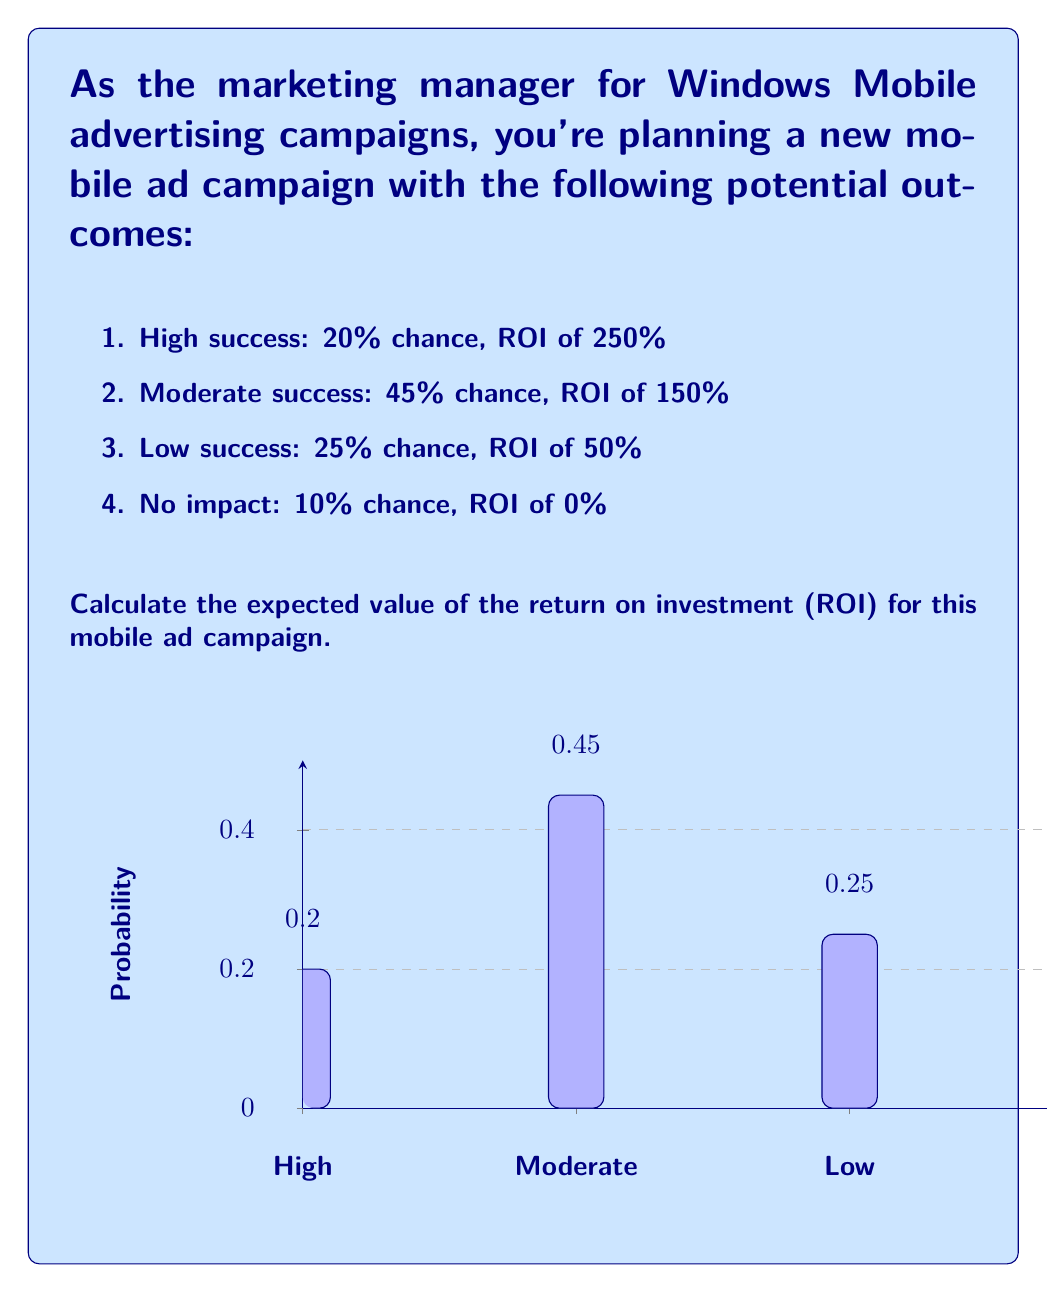Provide a solution to this math problem. To calculate the expected value of the ROI for this mobile ad campaign, we need to multiply each possible ROI by its probability of occurrence and then sum these products. Let's break it down step-by-step:

1) For each outcome, we calculate the product of its ROI and probability:

   High success: $0.20 \times 250\% = 50\%$
   Moderate success: $0.45 \times 150\% = 67.5\%$
   Low success: $0.25 \times 50\% = 12.5\%$
   No impact: $0.10 \times 0\% = 0\%$

2) Now, we sum these products to get the expected value:

   $E(\text{ROI}) = 50\% + 67.5\% + 12.5\% + 0\% = 130\%$

3) We can also express this calculation using the expected value formula:

   $$E(\text{ROI}) = \sum_{i=1}^{n} p_i \times \text{ROI}_i$$

   Where $p_i$ is the probability of each outcome and $\text{ROI}_i$ is the corresponding ROI.

   $$E(\text{ROI}) = (0.20 \times 250\%) + (0.45 \times 150\%) + (0.25 \times 50\%) + (0.10 \times 0\%)$$

   $$E(\text{ROI}) = 50\% + 67.5\% + 12.5\% + 0\% = 130\%$$

Therefore, the expected value of the ROI for this mobile ad campaign is 130%.
Answer: 130% 